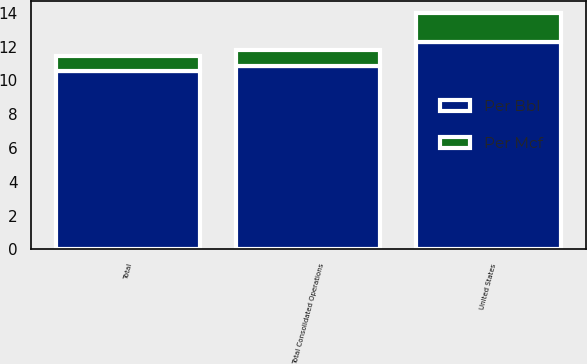Convert chart. <chart><loc_0><loc_0><loc_500><loc_500><stacked_bar_chart><ecel><fcel>United States<fcel>Total Consolidated Operations<fcel>Total<nl><fcel>Per Bbl<fcel>12.26<fcel>10.86<fcel>10.55<nl><fcel>Per Mcf<fcel>1.73<fcel>0.91<fcel>0.91<nl></chart> 